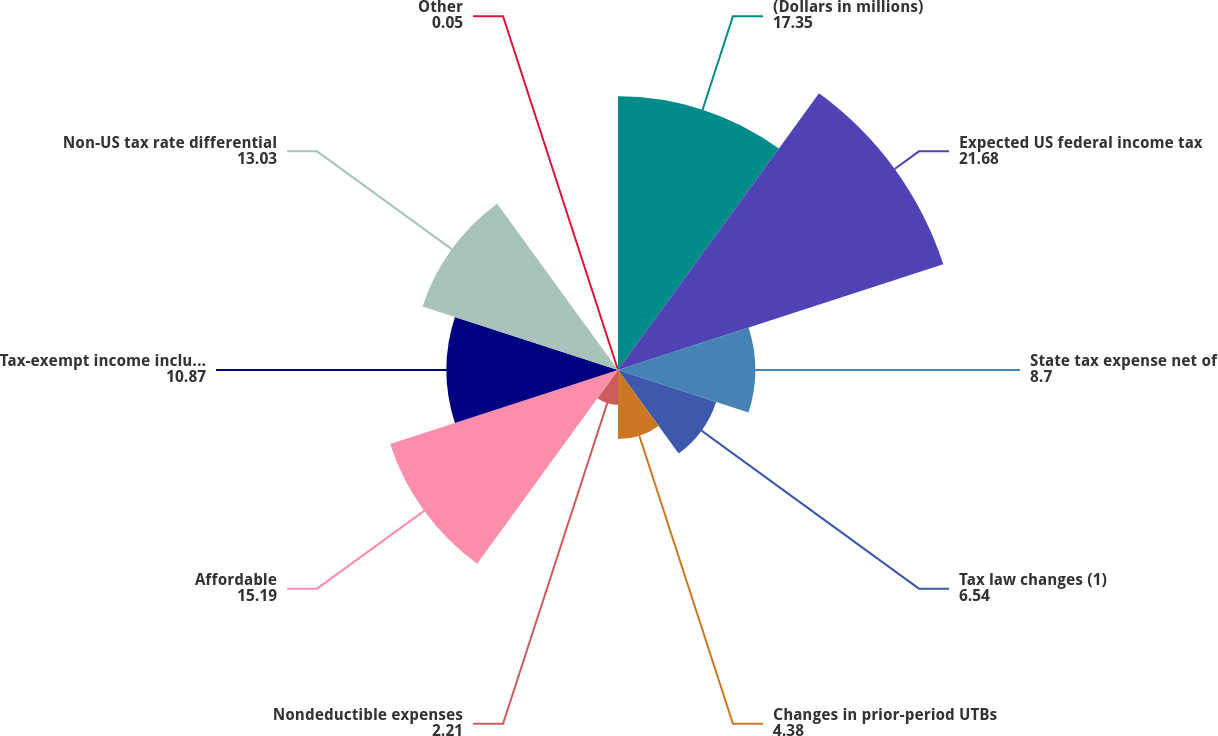Convert chart to OTSL. <chart><loc_0><loc_0><loc_500><loc_500><pie_chart><fcel>(Dollars in millions)<fcel>Expected US federal income tax<fcel>State tax expense net of<fcel>Tax law changes (1)<fcel>Changes in prior-period UTBs<fcel>Nondeductible expenses<fcel>Affordable<fcel>Tax-exempt income including<fcel>Non-US tax rate differential<fcel>Other<nl><fcel>17.35%<fcel>21.68%<fcel>8.7%<fcel>6.54%<fcel>4.38%<fcel>2.21%<fcel>15.19%<fcel>10.87%<fcel>13.03%<fcel>0.05%<nl></chart> 